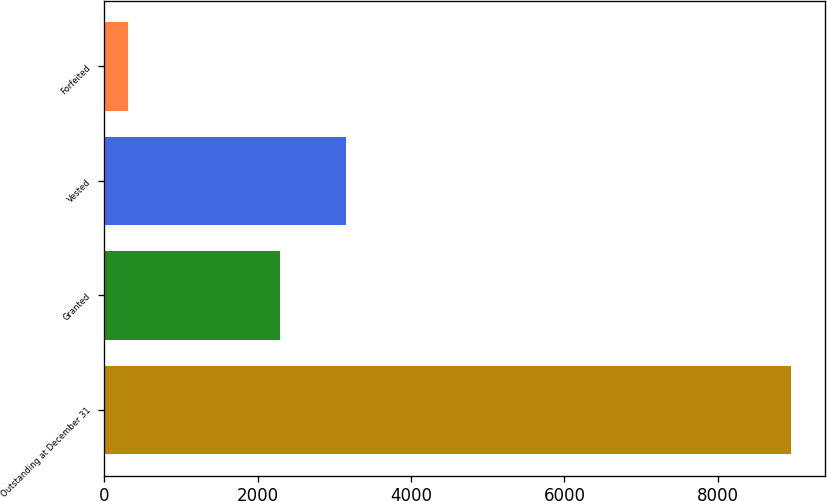<chart> <loc_0><loc_0><loc_500><loc_500><bar_chart><fcel>Outstanding at December 31<fcel>Granted<fcel>Vested<fcel>Forfeited<nl><fcel>8953<fcel>2287<fcel>3151<fcel>313<nl></chart> 